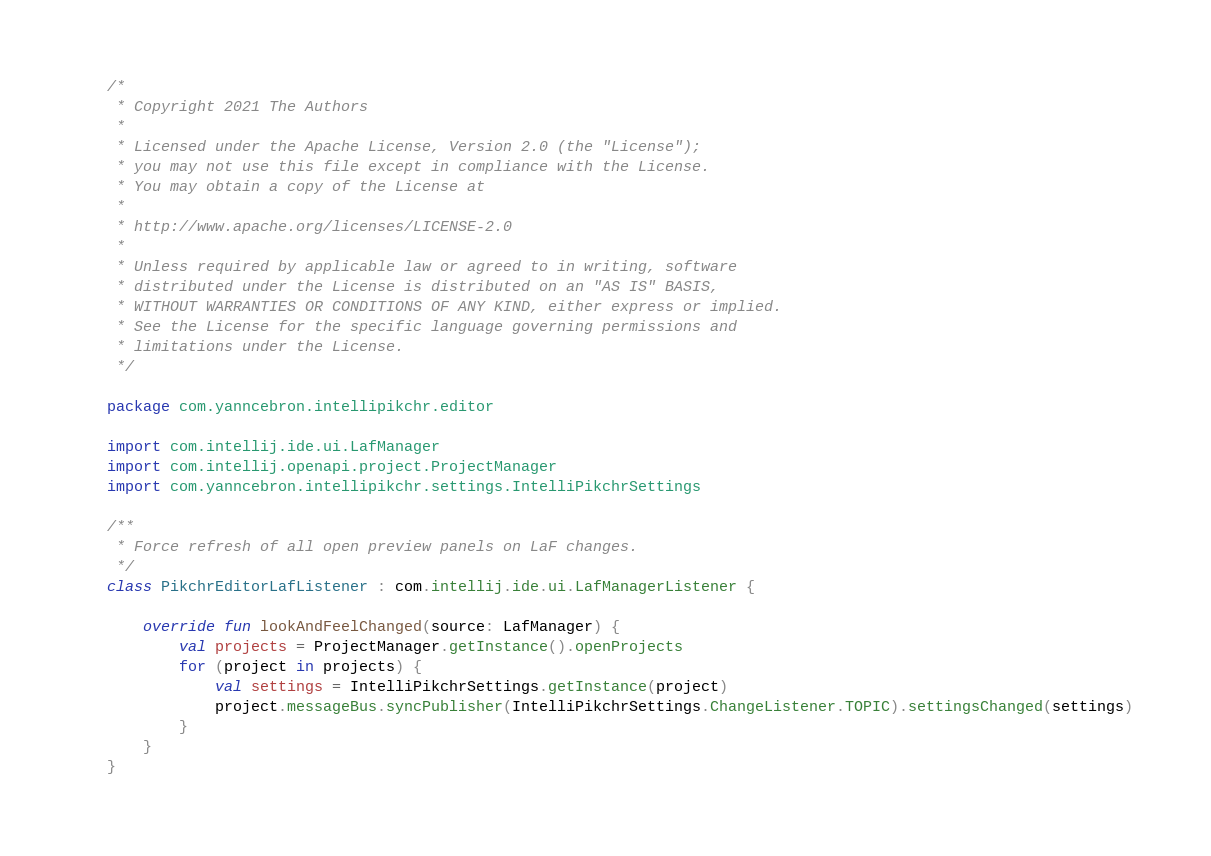Convert code to text. <code><loc_0><loc_0><loc_500><loc_500><_Kotlin_>/*
 * Copyright 2021 The Authors
 *
 * Licensed under the Apache License, Version 2.0 (the "License");
 * you may not use this file except in compliance with the License.
 * You may obtain a copy of the License at
 *
 * http://www.apache.org/licenses/LICENSE-2.0
 *
 * Unless required by applicable law or agreed to in writing, software
 * distributed under the License is distributed on an "AS IS" BASIS,
 * WITHOUT WARRANTIES OR CONDITIONS OF ANY KIND, either express or implied.
 * See the License for the specific language governing permissions and
 * limitations under the License.
 */

package com.yanncebron.intellipikchr.editor

import com.intellij.ide.ui.LafManager
import com.intellij.openapi.project.ProjectManager
import com.yanncebron.intellipikchr.settings.IntelliPikchrSettings

/**
 * Force refresh of all open preview panels on LaF changes.
 */
class PikchrEditorLafListener : com.intellij.ide.ui.LafManagerListener {

    override fun lookAndFeelChanged(source: LafManager) {
        val projects = ProjectManager.getInstance().openProjects
        for (project in projects) {
            val settings = IntelliPikchrSettings.getInstance(project)
            project.messageBus.syncPublisher(IntelliPikchrSettings.ChangeListener.TOPIC).settingsChanged(settings)
        }
    }
}</code> 